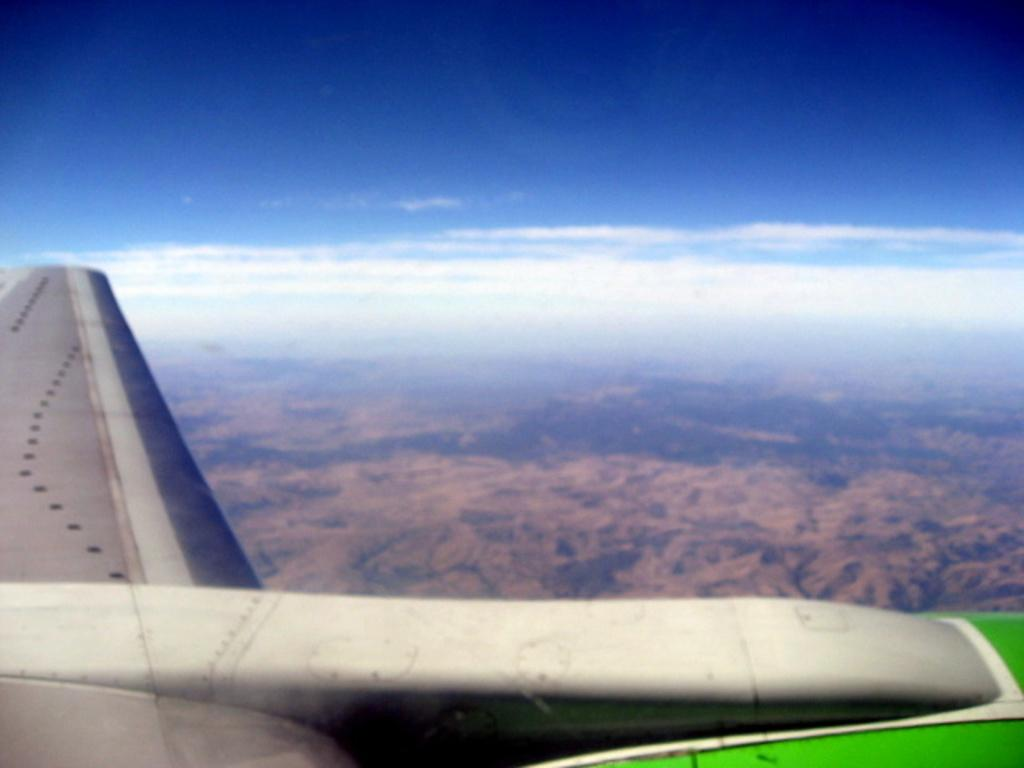What is the main subject of the picture? The main subject of the picture is an airplane. Does the airplane have any specific features? Yes, the airplane has a wing. What other geographical features can be seen in the picture? There is a mountain and trees visible on the ground. What type of yam is being harvested near the mountain in the image? There is no yam or harvesting activity present in the image; it features an airplane with a wing and a mountain with trees. Can you tell me how many grains of wheat are visible on the ground in the image? There is no grain or wheat visible on the ground in the image; it only shows an airplane, a mountain, and trees. 